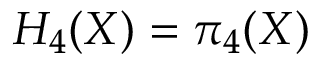Convert formula to latex. <formula><loc_0><loc_0><loc_500><loc_500>H _ { 4 } ( X ) = \pi _ { 4 } ( X )</formula> 